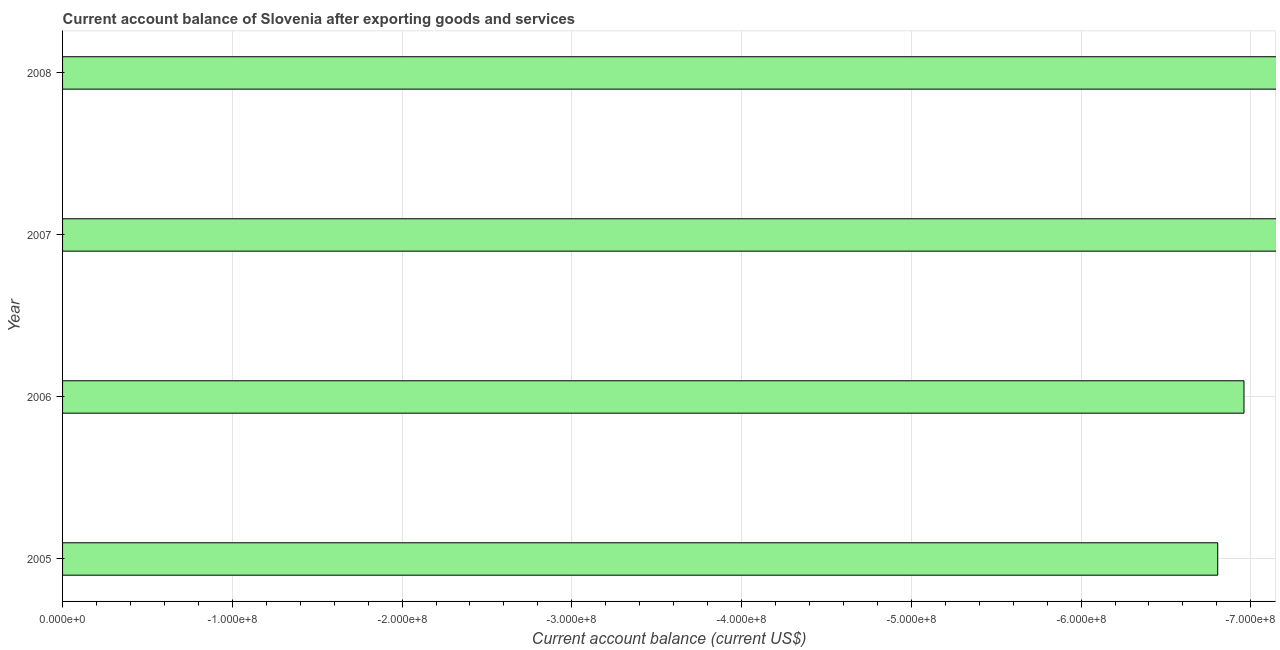What is the title of the graph?
Your answer should be compact. Current account balance of Slovenia after exporting goods and services. What is the label or title of the X-axis?
Give a very brief answer. Current account balance (current US$). What is the label or title of the Y-axis?
Provide a succinct answer. Year. What is the current account balance in 2007?
Your answer should be compact. 0. In how many years, is the current account balance greater than -520000000 US$?
Give a very brief answer. 0. In how many years, is the current account balance greater than the average current account balance taken over all years?
Your answer should be very brief. 0. How many bars are there?
Offer a very short reply. 0. Are all the bars in the graph horizontal?
Your answer should be compact. Yes. How many years are there in the graph?
Your answer should be very brief. 4. What is the difference between two consecutive major ticks on the X-axis?
Make the answer very short. 1.00e+08. Are the values on the major ticks of X-axis written in scientific E-notation?
Keep it short and to the point. Yes. What is the Current account balance (current US$) in 2005?
Keep it short and to the point. 0. What is the Current account balance (current US$) in 2006?
Make the answer very short. 0. What is the Current account balance (current US$) in 2007?
Make the answer very short. 0. 